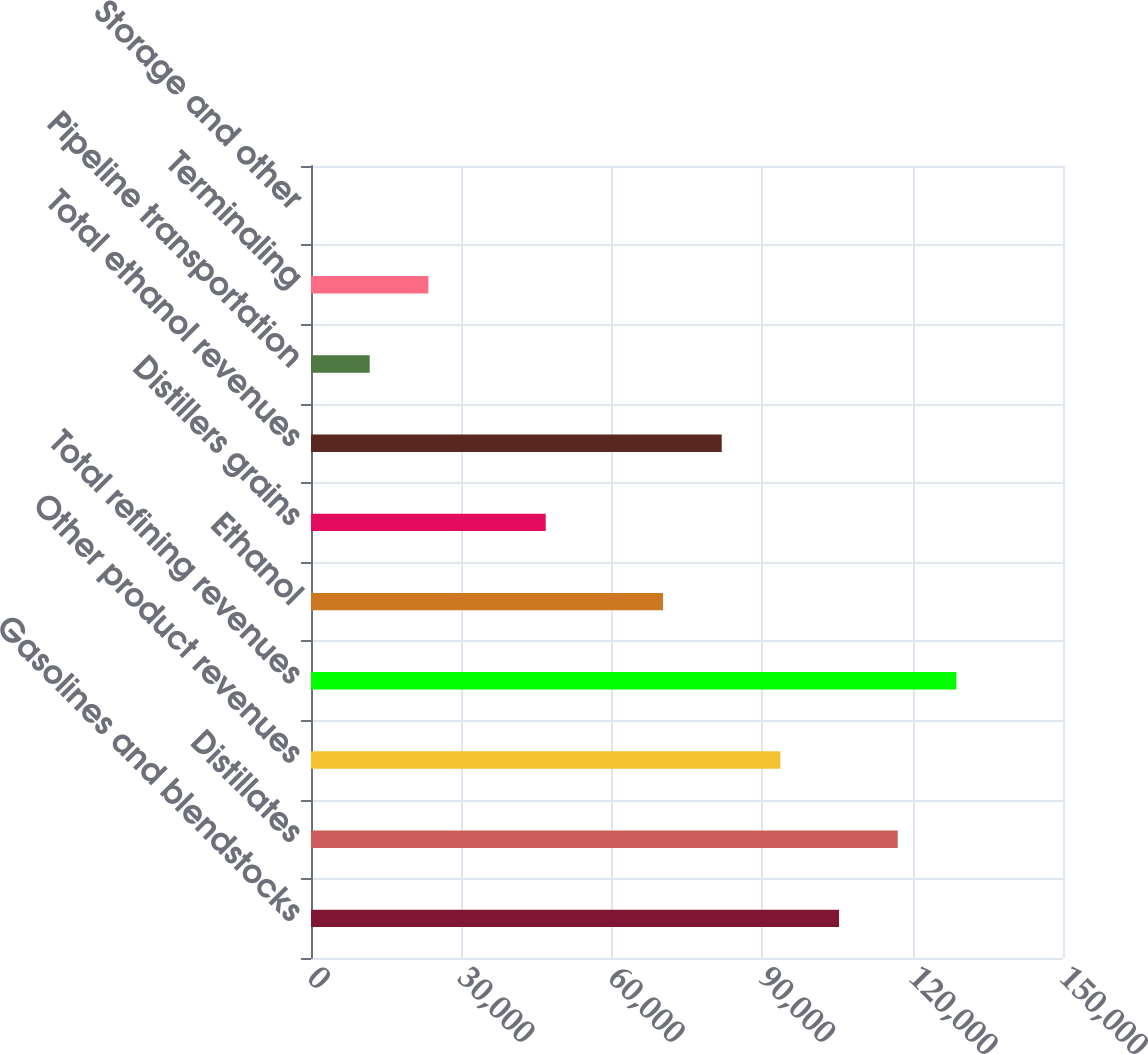Convert chart to OTSL. <chart><loc_0><loc_0><loc_500><loc_500><bar_chart><fcel>Gasolines and blendstocks<fcel>Distillates<fcel>Other product revenues<fcel>Total refining revenues<fcel>Ethanol<fcel>Distillers grains<fcel>Total ethanol revenues<fcel>Pipeline transportation<fcel>Terminaling<fcel>Storage and other<nl><fcel>105330<fcel>117033<fcel>93627.8<fcel>128736<fcel>70222.6<fcel>46817.4<fcel>81925.2<fcel>11709.6<fcel>23412.2<fcel>7<nl></chart> 